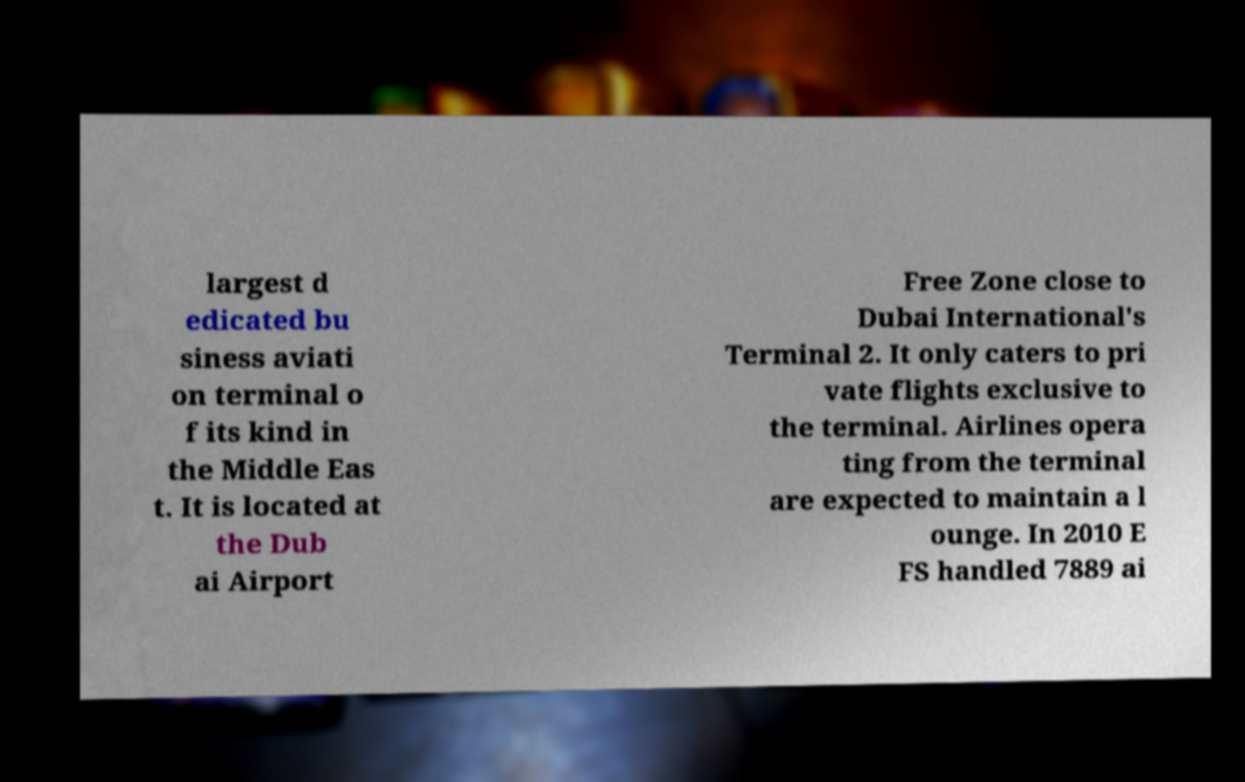For documentation purposes, I need the text within this image transcribed. Could you provide that? largest d edicated bu siness aviati on terminal o f its kind in the Middle Eas t. It is located at the Dub ai Airport Free Zone close to Dubai International's Terminal 2. It only caters to pri vate flights exclusive to the terminal. Airlines opera ting from the terminal are expected to maintain a l ounge. In 2010 E FS handled 7889 ai 